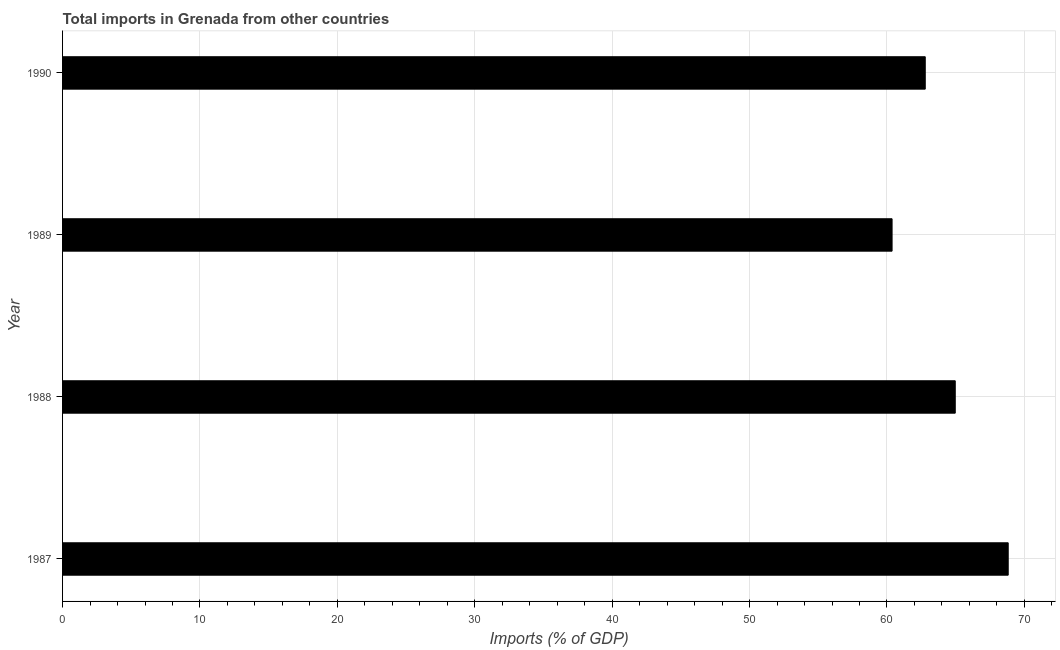What is the title of the graph?
Provide a short and direct response. Total imports in Grenada from other countries. What is the label or title of the X-axis?
Provide a succinct answer. Imports (% of GDP). What is the label or title of the Y-axis?
Your answer should be very brief. Year. What is the total imports in 1987?
Your answer should be very brief. 68.82. Across all years, what is the maximum total imports?
Your response must be concise. 68.82. Across all years, what is the minimum total imports?
Give a very brief answer. 60.37. In which year was the total imports minimum?
Make the answer very short. 1989. What is the sum of the total imports?
Make the answer very short. 256.95. What is the difference between the total imports in 1988 and 1989?
Keep it short and to the point. 4.6. What is the average total imports per year?
Provide a short and direct response. 64.24. What is the median total imports?
Give a very brief answer. 63.88. What is the ratio of the total imports in 1987 to that in 1989?
Offer a very short reply. 1.14. Is the difference between the total imports in 1988 and 1989 greater than the difference between any two years?
Your answer should be compact. No. What is the difference between the highest and the second highest total imports?
Provide a short and direct response. 3.85. What is the difference between the highest and the lowest total imports?
Offer a very short reply. 8.45. Are all the bars in the graph horizontal?
Provide a succinct answer. Yes. How many years are there in the graph?
Your answer should be very brief. 4. Are the values on the major ticks of X-axis written in scientific E-notation?
Provide a short and direct response. No. What is the Imports (% of GDP) in 1987?
Your response must be concise. 68.82. What is the Imports (% of GDP) in 1988?
Ensure brevity in your answer.  64.97. What is the Imports (% of GDP) of 1989?
Your answer should be compact. 60.37. What is the Imports (% of GDP) in 1990?
Your answer should be compact. 62.79. What is the difference between the Imports (% of GDP) in 1987 and 1988?
Your answer should be compact. 3.85. What is the difference between the Imports (% of GDP) in 1987 and 1989?
Give a very brief answer. 8.45. What is the difference between the Imports (% of GDP) in 1987 and 1990?
Keep it short and to the point. 6.04. What is the difference between the Imports (% of GDP) in 1988 and 1989?
Your response must be concise. 4.6. What is the difference between the Imports (% of GDP) in 1988 and 1990?
Give a very brief answer. 2.18. What is the difference between the Imports (% of GDP) in 1989 and 1990?
Make the answer very short. -2.41. What is the ratio of the Imports (% of GDP) in 1987 to that in 1988?
Offer a terse response. 1.06. What is the ratio of the Imports (% of GDP) in 1987 to that in 1989?
Your answer should be compact. 1.14. What is the ratio of the Imports (% of GDP) in 1987 to that in 1990?
Offer a terse response. 1.1. What is the ratio of the Imports (% of GDP) in 1988 to that in 1989?
Give a very brief answer. 1.08. What is the ratio of the Imports (% of GDP) in 1988 to that in 1990?
Give a very brief answer. 1.03. What is the ratio of the Imports (% of GDP) in 1989 to that in 1990?
Keep it short and to the point. 0.96. 